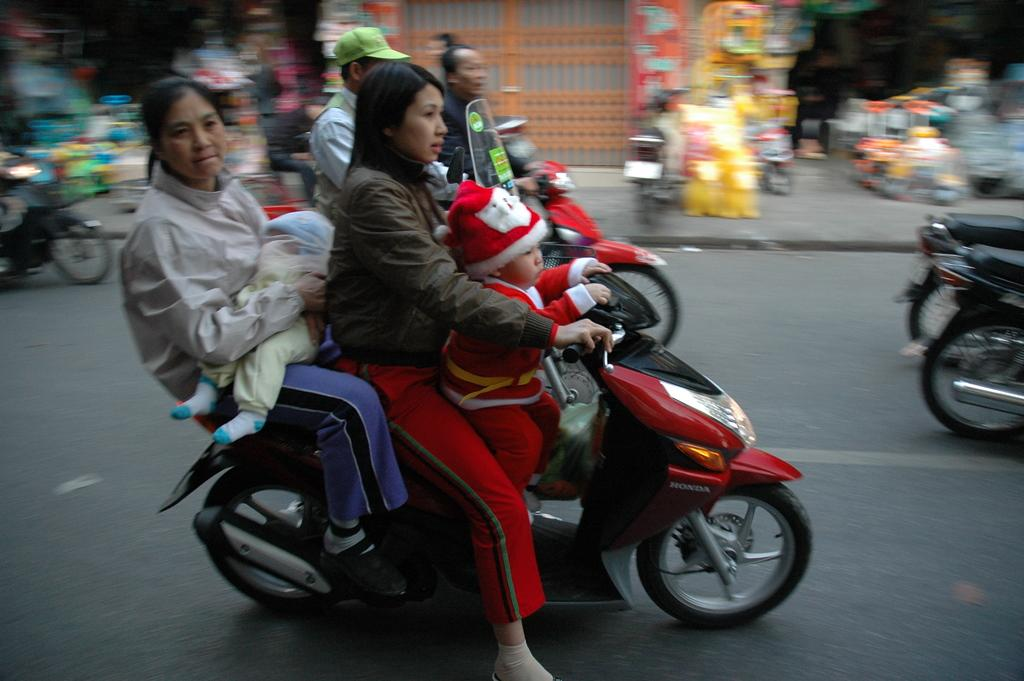How many people are in the image? There are two ladies in the image. How many children are in the image? There are two babies in the image. What are the ladies and babies doing in the image? The ladies and babies are on a bike. Where is the bike located in the image? The bike is on a road. What can be seen in the background of the image? There are stores visible in the image. How many lizards are crawling on the babies in the image? There are no lizards present in the image. What type of liquid is being used to clean the bike in the image? There is no liquid or cleaning activity depicted in the image. 